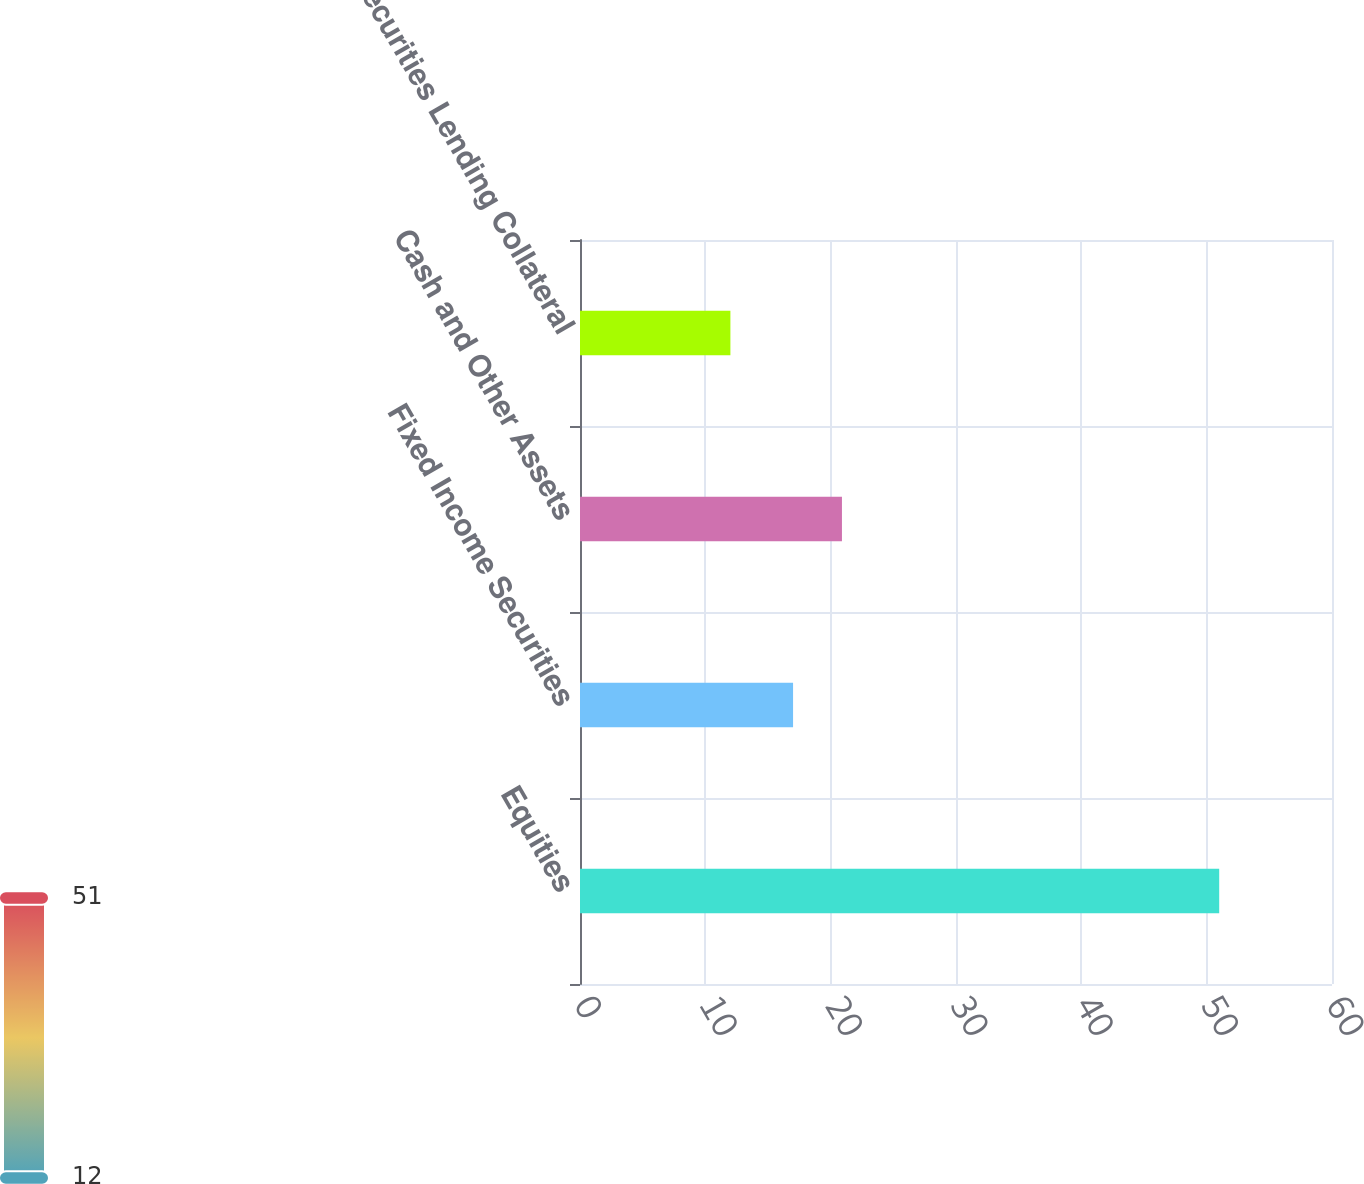Convert chart. <chart><loc_0><loc_0><loc_500><loc_500><bar_chart><fcel>Equities<fcel>Fixed Income Securities<fcel>Cash and Other Assets<fcel>Securities Lending Collateral<nl><fcel>51<fcel>17<fcel>20.9<fcel>12<nl></chart> 